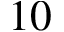Convert formula to latex. <formula><loc_0><loc_0><loc_500><loc_500>1 0</formula> 